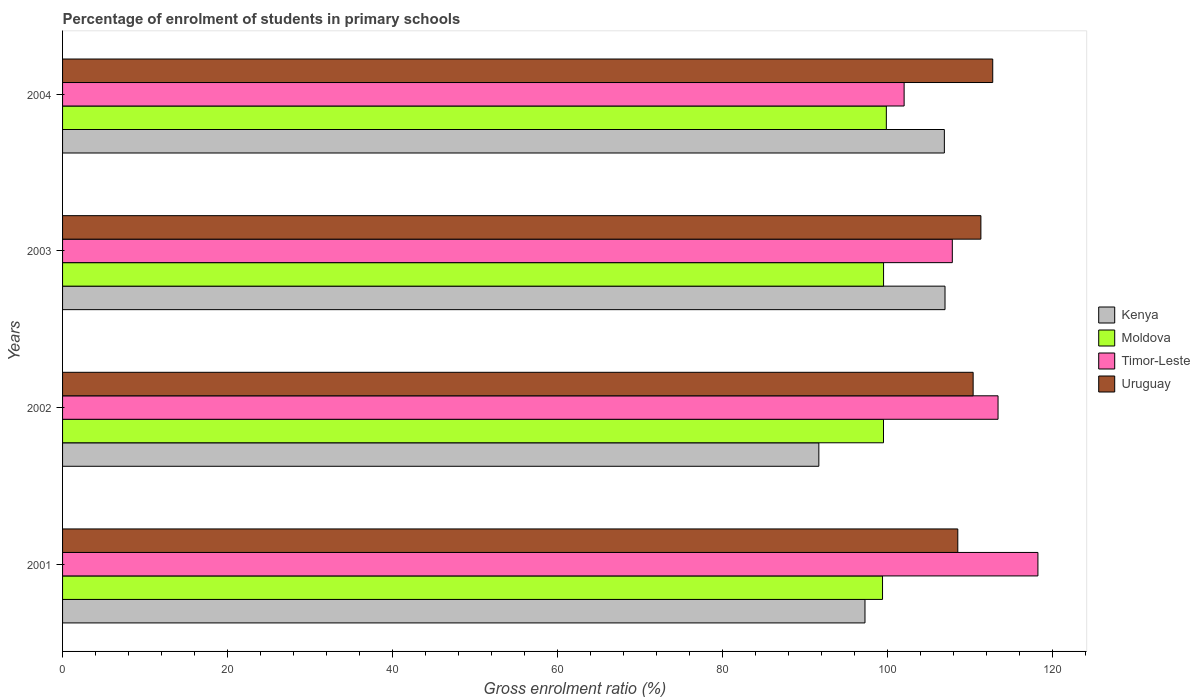How many groups of bars are there?
Offer a terse response. 4. How many bars are there on the 4th tick from the top?
Ensure brevity in your answer.  4. How many bars are there on the 3rd tick from the bottom?
Your response must be concise. 4. In how many cases, is the number of bars for a given year not equal to the number of legend labels?
Your response must be concise. 0. What is the percentage of students enrolled in primary schools in Timor-Leste in 2003?
Offer a terse response. 107.82. Across all years, what is the maximum percentage of students enrolled in primary schools in Kenya?
Your response must be concise. 106.93. Across all years, what is the minimum percentage of students enrolled in primary schools in Moldova?
Your answer should be compact. 99.36. What is the total percentage of students enrolled in primary schools in Timor-Leste in the graph?
Offer a very short reply. 441.35. What is the difference between the percentage of students enrolled in primary schools in Moldova in 2003 and that in 2004?
Offer a very short reply. -0.34. What is the difference between the percentage of students enrolled in primary schools in Timor-Leste in 2004 and the percentage of students enrolled in primary schools in Uruguay in 2003?
Give a very brief answer. -9.3. What is the average percentage of students enrolled in primary schools in Kenya per year?
Provide a succinct answer. 100.67. In the year 2001, what is the difference between the percentage of students enrolled in primary schools in Uruguay and percentage of students enrolled in primary schools in Kenya?
Your answer should be compact. 11.25. What is the ratio of the percentage of students enrolled in primary schools in Moldova in 2002 to that in 2003?
Your response must be concise. 1. Is the difference between the percentage of students enrolled in primary schools in Uruguay in 2001 and 2004 greater than the difference between the percentage of students enrolled in primary schools in Kenya in 2001 and 2004?
Offer a terse response. Yes. What is the difference between the highest and the second highest percentage of students enrolled in primary schools in Timor-Leste?
Provide a short and direct response. 4.83. What is the difference between the highest and the lowest percentage of students enrolled in primary schools in Uruguay?
Your answer should be compact. 4.23. What does the 4th bar from the top in 2001 represents?
Your answer should be very brief. Kenya. What does the 4th bar from the bottom in 2002 represents?
Provide a short and direct response. Uruguay. Is it the case that in every year, the sum of the percentage of students enrolled in primary schools in Kenya and percentage of students enrolled in primary schools in Timor-Leste is greater than the percentage of students enrolled in primary schools in Uruguay?
Provide a succinct answer. Yes. How many bars are there?
Ensure brevity in your answer.  16. How many years are there in the graph?
Make the answer very short. 4. Are the values on the major ticks of X-axis written in scientific E-notation?
Provide a short and direct response. No. Where does the legend appear in the graph?
Provide a short and direct response. Center right. How many legend labels are there?
Provide a succinct answer. 4. How are the legend labels stacked?
Keep it short and to the point. Vertical. What is the title of the graph?
Your answer should be very brief. Percentage of enrolment of students in primary schools. What is the label or title of the X-axis?
Keep it short and to the point. Gross enrolment ratio (%). What is the label or title of the Y-axis?
Your response must be concise. Years. What is the Gross enrolment ratio (%) of Kenya in 2001?
Keep it short and to the point. 97.24. What is the Gross enrolment ratio (%) of Moldova in 2001?
Keep it short and to the point. 99.36. What is the Gross enrolment ratio (%) of Timor-Leste in 2001?
Offer a very short reply. 118.19. What is the Gross enrolment ratio (%) in Uruguay in 2001?
Provide a short and direct response. 108.48. What is the Gross enrolment ratio (%) of Kenya in 2002?
Keep it short and to the point. 91.64. What is the Gross enrolment ratio (%) in Moldova in 2002?
Make the answer very short. 99.48. What is the Gross enrolment ratio (%) of Timor-Leste in 2002?
Your answer should be very brief. 113.36. What is the Gross enrolment ratio (%) of Uruguay in 2002?
Your response must be concise. 110.34. What is the Gross enrolment ratio (%) of Kenya in 2003?
Your answer should be very brief. 106.93. What is the Gross enrolment ratio (%) in Moldova in 2003?
Keep it short and to the point. 99.49. What is the Gross enrolment ratio (%) in Timor-Leste in 2003?
Provide a short and direct response. 107.82. What is the Gross enrolment ratio (%) of Uruguay in 2003?
Keep it short and to the point. 111.28. What is the Gross enrolment ratio (%) of Kenya in 2004?
Offer a very short reply. 106.85. What is the Gross enrolment ratio (%) of Moldova in 2004?
Your answer should be very brief. 99.82. What is the Gross enrolment ratio (%) in Timor-Leste in 2004?
Your answer should be compact. 101.98. What is the Gross enrolment ratio (%) in Uruguay in 2004?
Provide a succinct answer. 112.71. Across all years, what is the maximum Gross enrolment ratio (%) in Kenya?
Ensure brevity in your answer.  106.93. Across all years, what is the maximum Gross enrolment ratio (%) of Moldova?
Give a very brief answer. 99.82. Across all years, what is the maximum Gross enrolment ratio (%) in Timor-Leste?
Make the answer very short. 118.19. Across all years, what is the maximum Gross enrolment ratio (%) of Uruguay?
Offer a very short reply. 112.71. Across all years, what is the minimum Gross enrolment ratio (%) in Kenya?
Provide a succinct answer. 91.64. Across all years, what is the minimum Gross enrolment ratio (%) in Moldova?
Make the answer very short. 99.36. Across all years, what is the minimum Gross enrolment ratio (%) of Timor-Leste?
Provide a short and direct response. 101.98. Across all years, what is the minimum Gross enrolment ratio (%) of Uruguay?
Provide a succinct answer. 108.48. What is the total Gross enrolment ratio (%) of Kenya in the graph?
Make the answer very short. 402.66. What is the total Gross enrolment ratio (%) of Moldova in the graph?
Your answer should be very brief. 398.15. What is the total Gross enrolment ratio (%) in Timor-Leste in the graph?
Provide a succinct answer. 441.35. What is the total Gross enrolment ratio (%) of Uruguay in the graph?
Your answer should be very brief. 442.82. What is the difference between the Gross enrolment ratio (%) in Kenya in 2001 and that in 2002?
Offer a very short reply. 5.59. What is the difference between the Gross enrolment ratio (%) of Moldova in 2001 and that in 2002?
Your answer should be very brief. -0.12. What is the difference between the Gross enrolment ratio (%) in Timor-Leste in 2001 and that in 2002?
Offer a very short reply. 4.83. What is the difference between the Gross enrolment ratio (%) of Uruguay in 2001 and that in 2002?
Give a very brief answer. -1.86. What is the difference between the Gross enrolment ratio (%) in Kenya in 2001 and that in 2003?
Provide a short and direct response. -9.7. What is the difference between the Gross enrolment ratio (%) of Moldova in 2001 and that in 2003?
Offer a terse response. -0.13. What is the difference between the Gross enrolment ratio (%) of Timor-Leste in 2001 and that in 2003?
Your answer should be compact. 10.37. What is the difference between the Gross enrolment ratio (%) of Uruguay in 2001 and that in 2003?
Your answer should be compact. -2.8. What is the difference between the Gross enrolment ratio (%) in Kenya in 2001 and that in 2004?
Make the answer very short. -9.62. What is the difference between the Gross enrolment ratio (%) of Moldova in 2001 and that in 2004?
Offer a very short reply. -0.46. What is the difference between the Gross enrolment ratio (%) of Timor-Leste in 2001 and that in 2004?
Your answer should be very brief. 16.21. What is the difference between the Gross enrolment ratio (%) of Uruguay in 2001 and that in 2004?
Provide a succinct answer. -4.23. What is the difference between the Gross enrolment ratio (%) of Kenya in 2002 and that in 2003?
Offer a terse response. -15.29. What is the difference between the Gross enrolment ratio (%) in Moldova in 2002 and that in 2003?
Your answer should be very brief. -0.01. What is the difference between the Gross enrolment ratio (%) in Timor-Leste in 2002 and that in 2003?
Keep it short and to the point. 5.54. What is the difference between the Gross enrolment ratio (%) in Uruguay in 2002 and that in 2003?
Keep it short and to the point. -0.94. What is the difference between the Gross enrolment ratio (%) of Kenya in 2002 and that in 2004?
Give a very brief answer. -15.21. What is the difference between the Gross enrolment ratio (%) in Moldova in 2002 and that in 2004?
Make the answer very short. -0.34. What is the difference between the Gross enrolment ratio (%) of Timor-Leste in 2002 and that in 2004?
Your answer should be very brief. 11.38. What is the difference between the Gross enrolment ratio (%) of Uruguay in 2002 and that in 2004?
Offer a very short reply. -2.37. What is the difference between the Gross enrolment ratio (%) of Kenya in 2003 and that in 2004?
Ensure brevity in your answer.  0.08. What is the difference between the Gross enrolment ratio (%) in Moldova in 2003 and that in 2004?
Offer a very short reply. -0.34. What is the difference between the Gross enrolment ratio (%) of Timor-Leste in 2003 and that in 2004?
Provide a succinct answer. 5.84. What is the difference between the Gross enrolment ratio (%) in Uruguay in 2003 and that in 2004?
Give a very brief answer. -1.43. What is the difference between the Gross enrolment ratio (%) in Kenya in 2001 and the Gross enrolment ratio (%) in Moldova in 2002?
Your response must be concise. -2.24. What is the difference between the Gross enrolment ratio (%) in Kenya in 2001 and the Gross enrolment ratio (%) in Timor-Leste in 2002?
Keep it short and to the point. -16.12. What is the difference between the Gross enrolment ratio (%) in Kenya in 2001 and the Gross enrolment ratio (%) in Uruguay in 2002?
Give a very brief answer. -13.1. What is the difference between the Gross enrolment ratio (%) of Moldova in 2001 and the Gross enrolment ratio (%) of Timor-Leste in 2002?
Keep it short and to the point. -14. What is the difference between the Gross enrolment ratio (%) of Moldova in 2001 and the Gross enrolment ratio (%) of Uruguay in 2002?
Offer a terse response. -10.98. What is the difference between the Gross enrolment ratio (%) of Timor-Leste in 2001 and the Gross enrolment ratio (%) of Uruguay in 2002?
Provide a short and direct response. 7.85. What is the difference between the Gross enrolment ratio (%) in Kenya in 2001 and the Gross enrolment ratio (%) in Moldova in 2003?
Ensure brevity in your answer.  -2.25. What is the difference between the Gross enrolment ratio (%) in Kenya in 2001 and the Gross enrolment ratio (%) in Timor-Leste in 2003?
Make the answer very short. -10.58. What is the difference between the Gross enrolment ratio (%) in Kenya in 2001 and the Gross enrolment ratio (%) in Uruguay in 2003?
Provide a succinct answer. -14.04. What is the difference between the Gross enrolment ratio (%) of Moldova in 2001 and the Gross enrolment ratio (%) of Timor-Leste in 2003?
Offer a terse response. -8.46. What is the difference between the Gross enrolment ratio (%) of Moldova in 2001 and the Gross enrolment ratio (%) of Uruguay in 2003?
Your answer should be very brief. -11.92. What is the difference between the Gross enrolment ratio (%) of Timor-Leste in 2001 and the Gross enrolment ratio (%) of Uruguay in 2003?
Keep it short and to the point. 6.91. What is the difference between the Gross enrolment ratio (%) in Kenya in 2001 and the Gross enrolment ratio (%) in Moldova in 2004?
Ensure brevity in your answer.  -2.59. What is the difference between the Gross enrolment ratio (%) of Kenya in 2001 and the Gross enrolment ratio (%) of Timor-Leste in 2004?
Keep it short and to the point. -4.74. What is the difference between the Gross enrolment ratio (%) of Kenya in 2001 and the Gross enrolment ratio (%) of Uruguay in 2004?
Your response must be concise. -15.48. What is the difference between the Gross enrolment ratio (%) in Moldova in 2001 and the Gross enrolment ratio (%) in Timor-Leste in 2004?
Offer a very short reply. -2.62. What is the difference between the Gross enrolment ratio (%) in Moldova in 2001 and the Gross enrolment ratio (%) in Uruguay in 2004?
Provide a short and direct response. -13.35. What is the difference between the Gross enrolment ratio (%) in Timor-Leste in 2001 and the Gross enrolment ratio (%) in Uruguay in 2004?
Offer a very short reply. 5.48. What is the difference between the Gross enrolment ratio (%) of Kenya in 2002 and the Gross enrolment ratio (%) of Moldova in 2003?
Offer a very short reply. -7.84. What is the difference between the Gross enrolment ratio (%) in Kenya in 2002 and the Gross enrolment ratio (%) in Timor-Leste in 2003?
Your answer should be compact. -16.17. What is the difference between the Gross enrolment ratio (%) of Kenya in 2002 and the Gross enrolment ratio (%) of Uruguay in 2003?
Give a very brief answer. -19.64. What is the difference between the Gross enrolment ratio (%) in Moldova in 2002 and the Gross enrolment ratio (%) in Timor-Leste in 2003?
Give a very brief answer. -8.34. What is the difference between the Gross enrolment ratio (%) in Moldova in 2002 and the Gross enrolment ratio (%) in Uruguay in 2003?
Ensure brevity in your answer.  -11.8. What is the difference between the Gross enrolment ratio (%) in Timor-Leste in 2002 and the Gross enrolment ratio (%) in Uruguay in 2003?
Provide a short and direct response. 2.08. What is the difference between the Gross enrolment ratio (%) of Kenya in 2002 and the Gross enrolment ratio (%) of Moldova in 2004?
Ensure brevity in your answer.  -8.18. What is the difference between the Gross enrolment ratio (%) of Kenya in 2002 and the Gross enrolment ratio (%) of Timor-Leste in 2004?
Your answer should be compact. -10.34. What is the difference between the Gross enrolment ratio (%) in Kenya in 2002 and the Gross enrolment ratio (%) in Uruguay in 2004?
Your answer should be very brief. -21.07. What is the difference between the Gross enrolment ratio (%) in Moldova in 2002 and the Gross enrolment ratio (%) in Timor-Leste in 2004?
Ensure brevity in your answer.  -2.5. What is the difference between the Gross enrolment ratio (%) in Moldova in 2002 and the Gross enrolment ratio (%) in Uruguay in 2004?
Offer a terse response. -13.24. What is the difference between the Gross enrolment ratio (%) in Timor-Leste in 2002 and the Gross enrolment ratio (%) in Uruguay in 2004?
Offer a very short reply. 0.64. What is the difference between the Gross enrolment ratio (%) in Kenya in 2003 and the Gross enrolment ratio (%) in Moldova in 2004?
Make the answer very short. 7.11. What is the difference between the Gross enrolment ratio (%) in Kenya in 2003 and the Gross enrolment ratio (%) in Timor-Leste in 2004?
Your response must be concise. 4.95. What is the difference between the Gross enrolment ratio (%) in Kenya in 2003 and the Gross enrolment ratio (%) in Uruguay in 2004?
Make the answer very short. -5.78. What is the difference between the Gross enrolment ratio (%) in Moldova in 2003 and the Gross enrolment ratio (%) in Timor-Leste in 2004?
Your answer should be very brief. -2.49. What is the difference between the Gross enrolment ratio (%) of Moldova in 2003 and the Gross enrolment ratio (%) of Uruguay in 2004?
Provide a short and direct response. -13.23. What is the difference between the Gross enrolment ratio (%) in Timor-Leste in 2003 and the Gross enrolment ratio (%) in Uruguay in 2004?
Your answer should be compact. -4.9. What is the average Gross enrolment ratio (%) of Kenya per year?
Offer a very short reply. 100.67. What is the average Gross enrolment ratio (%) in Moldova per year?
Keep it short and to the point. 99.54. What is the average Gross enrolment ratio (%) in Timor-Leste per year?
Provide a succinct answer. 110.34. What is the average Gross enrolment ratio (%) in Uruguay per year?
Your answer should be very brief. 110.7. In the year 2001, what is the difference between the Gross enrolment ratio (%) of Kenya and Gross enrolment ratio (%) of Moldova?
Keep it short and to the point. -2.13. In the year 2001, what is the difference between the Gross enrolment ratio (%) of Kenya and Gross enrolment ratio (%) of Timor-Leste?
Provide a succinct answer. -20.96. In the year 2001, what is the difference between the Gross enrolment ratio (%) in Kenya and Gross enrolment ratio (%) in Uruguay?
Make the answer very short. -11.25. In the year 2001, what is the difference between the Gross enrolment ratio (%) in Moldova and Gross enrolment ratio (%) in Timor-Leste?
Provide a short and direct response. -18.83. In the year 2001, what is the difference between the Gross enrolment ratio (%) in Moldova and Gross enrolment ratio (%) in Uruguay?
Your answer should be very brief. -9.12. In the year 2001, what is the difference between the Gross enrolment ratio (%) of Timor-Leste and Gross enrolment ratio (%) of Uruguay?
Offer a very short reply. 9.71. In the year 2002, what is the difference between the Gross enrolment ratio (%) of Kenya and Gross enrolment ratio (%) of Moldova?
Offer a very short reply. -7.84. In the year 2002, what is the difference between the Gross enrolment ratio (%) of Kenya and Gross enrolment ratio (%) of Timor-Leste?
Make the answer very short. -21.72. In the year 2002, what is the difference between the Gross enrolment ratio (%) in Kenya and Gross enrolment ratio (%) in Uruguay?
Your answer should be very brief. -18.7. In the year 2002, what is the difference between the Gross enrolment ratio (%) in Moldova and Gross enrolment ratio (%) in Timor-Leste?
Provide a short and direct response. -13.88. In the year 2002, what is the difference between the Gross enrolment ratio (%) in Moldova and Gross enrolment ratio (%) in Uruguay?
Give a very brief answer. -10.86. In the year 2002, what is the difference between the Gross enrolment ratio (%) in Timor-Leste and Gross enrolment ratio (%) in Uruguay?
Ensure brevity in your answer.  3.02. In the year 2003, what is the difference between the Gross enrolment ratio (%) of Kenya and Gross enrolment ratio (%) of Moldova?
Give a very brief answer. 7.45. In the year 2003, what is the difference between the Gross enrolment ratio (%) in Kenya and Gross enrolment ratio (%) in Timor-Leste?
Offer a very short reply. -0.88. In the year 2003, what is the difference between the Gross enrolment ratio (%) in Kenya and Gross enrolment ratio (%) in Uruguay?
Make the answer very short. -4.35. In the year 2003, what is the difference between the Gross enrolment ratio (%) of Moldova and Gross enrolment ratio (%) of Timor-Leste?
Provide a short and direct response. -8.33. In the year 2003, what is the difference between the Gross enrolment ratio (%) in Moldova and Gross enrolment ratio (%) in Uruguay?
Make the answer very short. -11.79. In the year 2003, what is the difference between the Gross enrolment ratio (%) of Timor-Leste and Gross enrolment ratio (%) of Uruguay?
Your response must be concise. -3.46. In the year 2004, what is the difference between the Gross enrolment ratio (%) in Kenya and Gross enrolment ratio (%) in Moldova?
Your answer should be very brief. 7.03. In the year 2004, what is the difference between the Gross enrolment ratio (%) in Kenya and Gross enrolment ratio (%) in Timor-Leste?
Your response must be concise. 4.87. In the year 2004, what is the difference between the Gross enrolment ratio (%) in Kenya and Gross enrolment ratio (%) in Uruguay?
Offer a very short reply. -5.86. In the year 2004, what is the difference between the Gross enrolment ratio (%) of Moldova and Gross enrolment ratio (%) of Timor-Leste?
Offer a terse response. -2.16. In the year 2004, what is the difference between the Gross enrolment ratio (%) in Moldova and Gross enrolment ratio (%) in Uruguay?
Your answer should be very brief. -12.89. In the year 2004, what is the difference between the Gross enrolment ratio (%) in Timor-Leste and Gross enrolment ratio (%) in Uruguay?
Your answer should be very brief. -10.74. What is the ratio of the Gross enrolment ratio (%) in Kenya in 2001 to that in 2002?
Make the answer very short. 1.06. What is the ratio of the Gross enrolment ratio (%) of Timor-Leste in 2001 to that in 2002?
Provide a succinct answer. 1.04. What is the ratio of the Gross enrolment ratio (%) of Uruguay in 2001 to that in 2002?
Make the answer very short. 0.98. What is the ratio of the Gross enrolment ratio (%) in Kenya in 2001 to that in 2003?
Make the answer very short. 0.91. What is the ratio of the Gross enrolment ratio (%) in Moldova in 2001 to that in 2003?
Your answer should be very brief. 1. What is the ratio of the Gross enrolment ratio (%) in Timor-Leste in 2001 to that in 2003?
Make the answer very short. 1.1. What is the ratio of the Gross enrolment ratio (%) in Uruguay in 2001 to that in 2003?
Your answer should be compact. 0.97. What is the ratio of the Gross enrolment ratio (%) in Kenya in 2001 to that in 2004?
Offer a terse response. 0.91. What is the ratio of the Gross enrolment ratio (%) in Timor-Leste in 2001 to that in 2004?
Your answer should be very brief. 1.16. What is the ratio of the Gross enrolment ratio (%) of Uruguay in 2001 to that in 2004?
Keep it short and to the point. 0.96. What is the ratio of the Gross enrolment ratio (%) in Kenya in 2002 to that in 2003?
Provide a succinct answer. 0.86. What is the ratio of the Gross enrolment ratio (%) in Timor-Leste in 2002 to that in 2003?
Make the answer very short. 1.05. What is the ratio of the Gross enrolment ratio (%) of Uruguay in 2002 to that in 2003?
Give a very brief answer. 0.99. What is the ratio of the Gross enrolment ratio (%) of Kenya in 2002 to that in 2004?
Offer a terse response. 0.86. What is the ratio of the Gross enrolment ratio (%) in Timor-Leste in 2002 to that in 2004?
Offer a very short reply. 1.11. What is the ratio of the Gross enrolment ratio (%) in Uruguay in 2002 to that in 2004?
Your answer should be very brief. 0.98. What is the ratio of the Gross enrolment ratio (%) in Kenya in 2003 to that in 2004?
Provide a succinct answer. 1. What is the ratio of the Gross enrolment ratio (%) in Moldova in 2003 to that in 2004?
Ensure brevity in your answer.  1. What is the ratio of the Gross enrolment ratio (%) in Timor-Leste in 2003 to that in 2004?
Offer a terse response. 1.06. What is the ratio of the Gross enrolment ratio (%) in Uruguay in 2003 to that in 2004?
Your answer should be very brief. 0.99. What is the difference between the highest and the second highest Gross enrolment ratio (%) of Kenya?
Give a very brief answer. 0.08. What is the difference between the highest and the second highest Gross enrolment ratio (%) of Moldova?
Your response must be concise. 0.34. What is the difference between the highest and the second highest Gross enrolment ratio (%) of Timor-Leste?
Keep it short and to the point. 4.83. What is the difference between the highest and the second highest Gross enrolment ratio (%) in Uruguay?
Provide a short and direct response. 1.43. What is the difference between the highest and the lowest Gross enrolment ratio (%) of Kenya?
Make the answer very short. 15.29. What is the difference between the highest and the lowest Gross enrolment ratio (%) in Moldova?
Provide a short and direct response. 0.46. What is the difference between the highest and the lowest Gross enrolment ratio (%) of Timor-Leste?
Your answer should be compact. 16.21. What is the difference between the highest and the lowest Gross enrolment ratio (%) of Uruguay?
Keep it short and to the point. 4.23. 